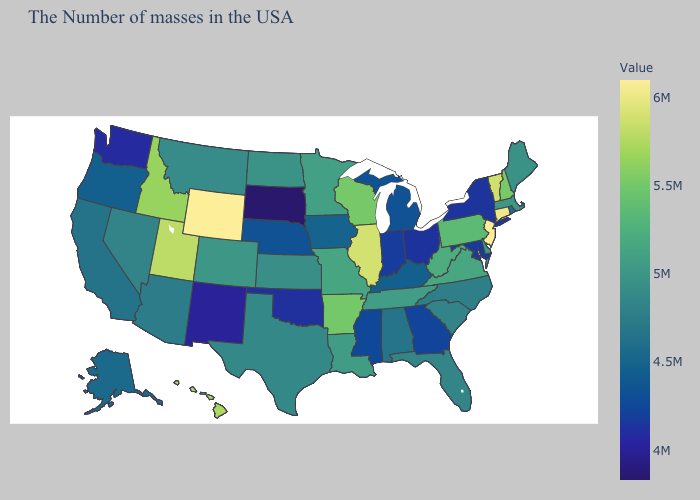Which states have the lowest value in the MidWest?
Concise answer only. South Dakota. Among the states that border Alabama , does Tennessee have the lowest value?
Give a very brief answer. No. Which states have the lowest value in the South?
Concise answer only. Oklahoma. Among the states that border Pennsylvania , does New York have the lowest value?
Concise answer only. No. Among the states that border Vermont , does New Hampshire have the highest value?
Be succinct. Yes. Does South Dakota have the lowest value in the USA?
Answer briefly. Yes. 